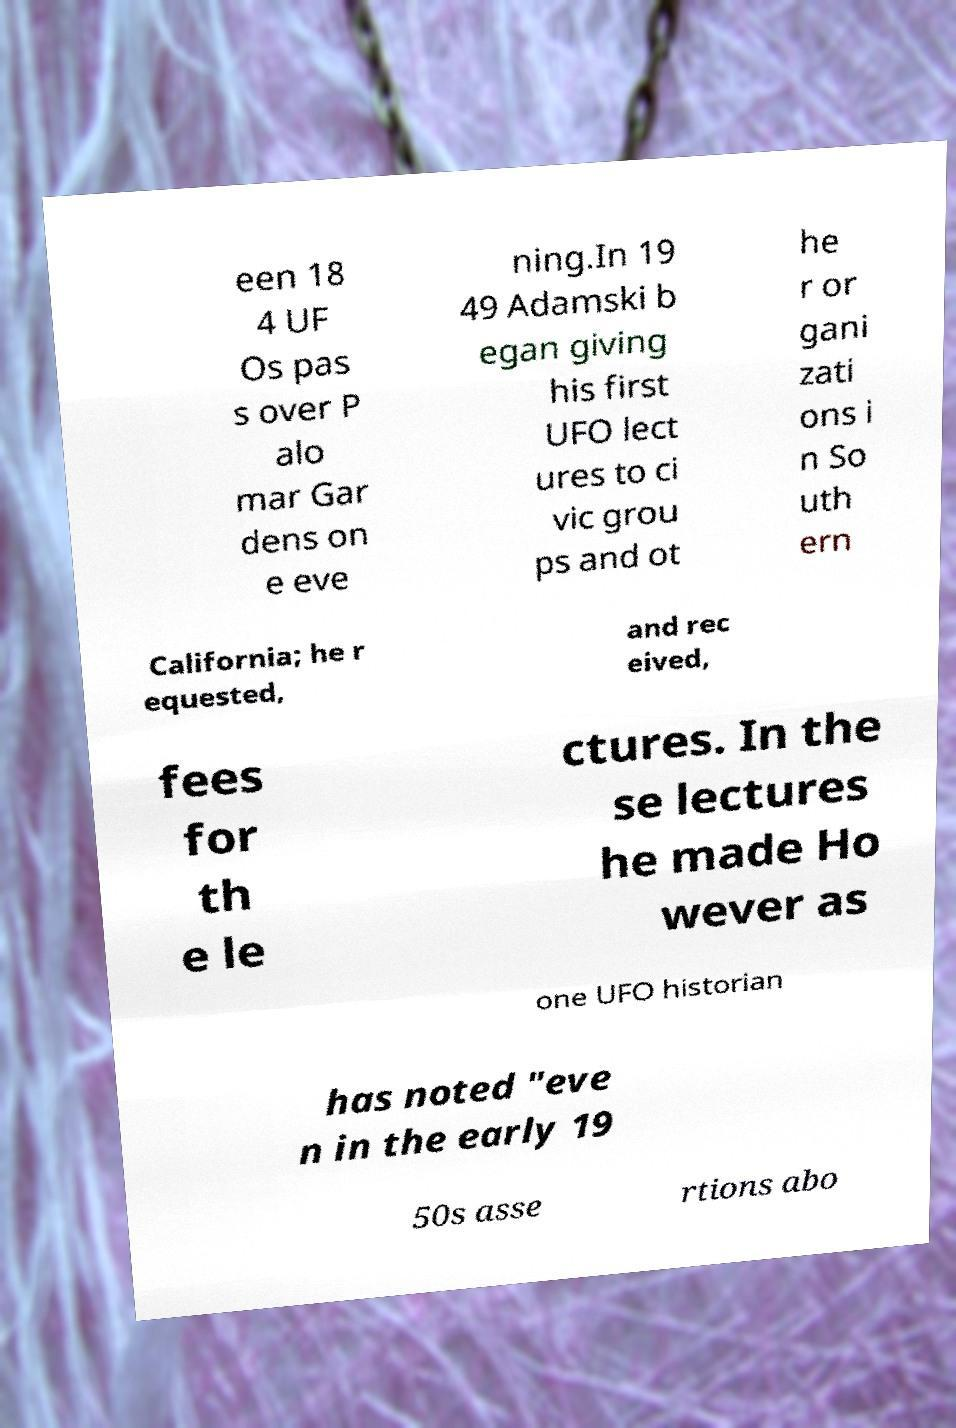Could you extract and type out the text from this image? een 18 4 UF Os pas s over P alo mar Gar dens on e eve ning.In 19 49 Adamski b egan giving his first UFO lect ures to ci vic grou ps and ot he r or gani zati ons i n So uth ern California; he r equested, and rec eived, fees for th e le ctures. In the se lectures he made Ho wever as one UFO historian has noted "eve n in the early 19 50s asse rtions abo 